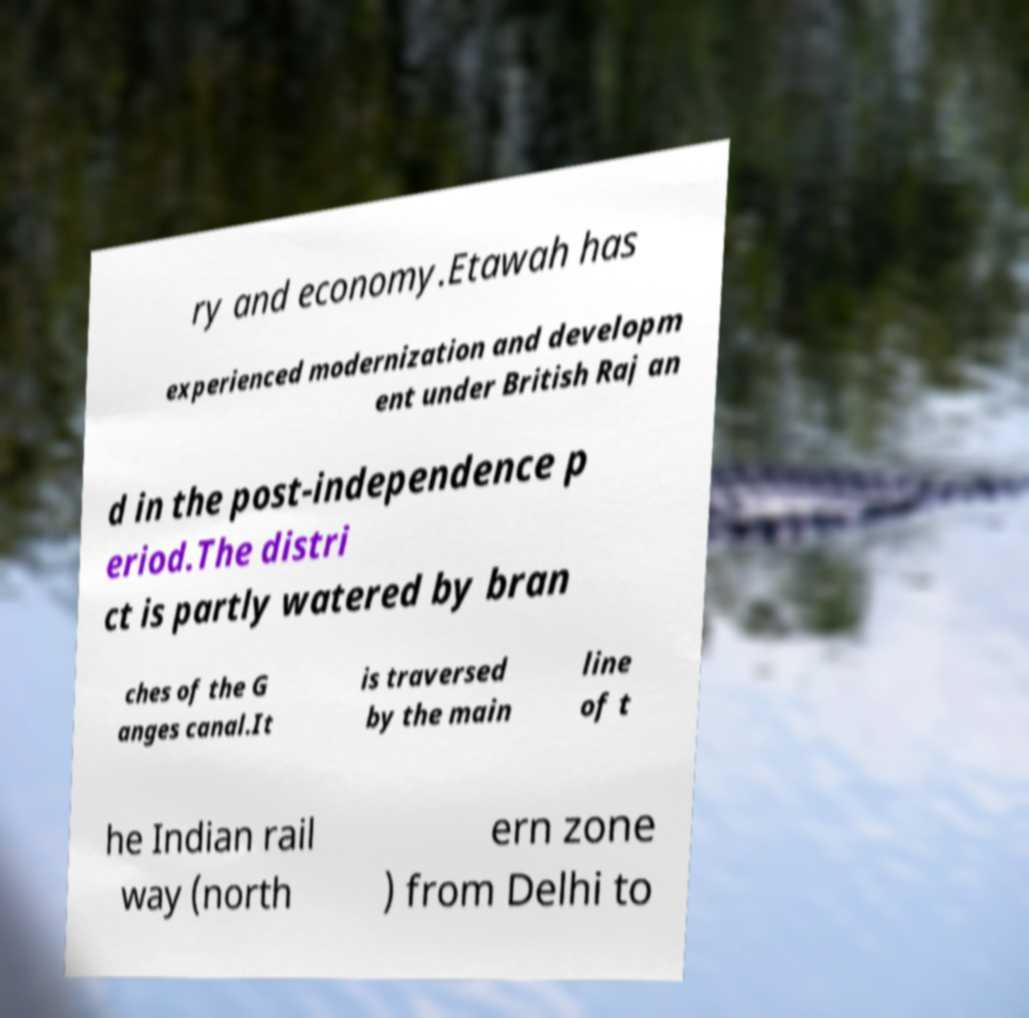For documentation purposes, I need the text within this image transcribed. Could you provide that? ry and economy.Etawah has experienced modernization and developm ent under British Raj an d in the post-independence p eriod.The distri ct is partly watered by bran ches of the G anges canal.It is traversed by the main line of t he Indian rail way (north ern zone ) from Delhi to 